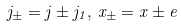Convert formula to latex. <formula><loc_0><loc_0><loc_500><loc_500>j _ { \pm } = j \pm j _ { 1 } , \, x _ { \pm } = x \pm e</formula> 